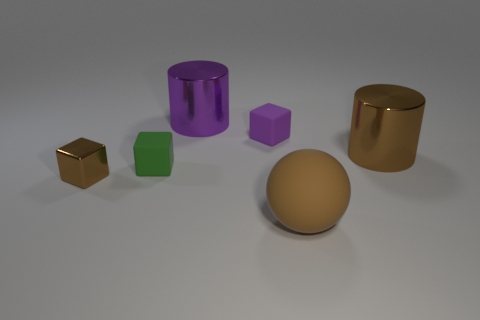Add 3 large red matte balls. How many objects exist? 9 Subtract all cylinders. How many objects are left? 4 Subtract all cyan matte blocks. Subtract all big shiny cylinders. How many objects are left? 4 Add 2 large brown metal cylinders. How many large brown metal cylinders are left? 3 Add 5 gray balls. How many gray balls exist? 5 Subtract 1 purple cylinders. How many objects are left? 5 